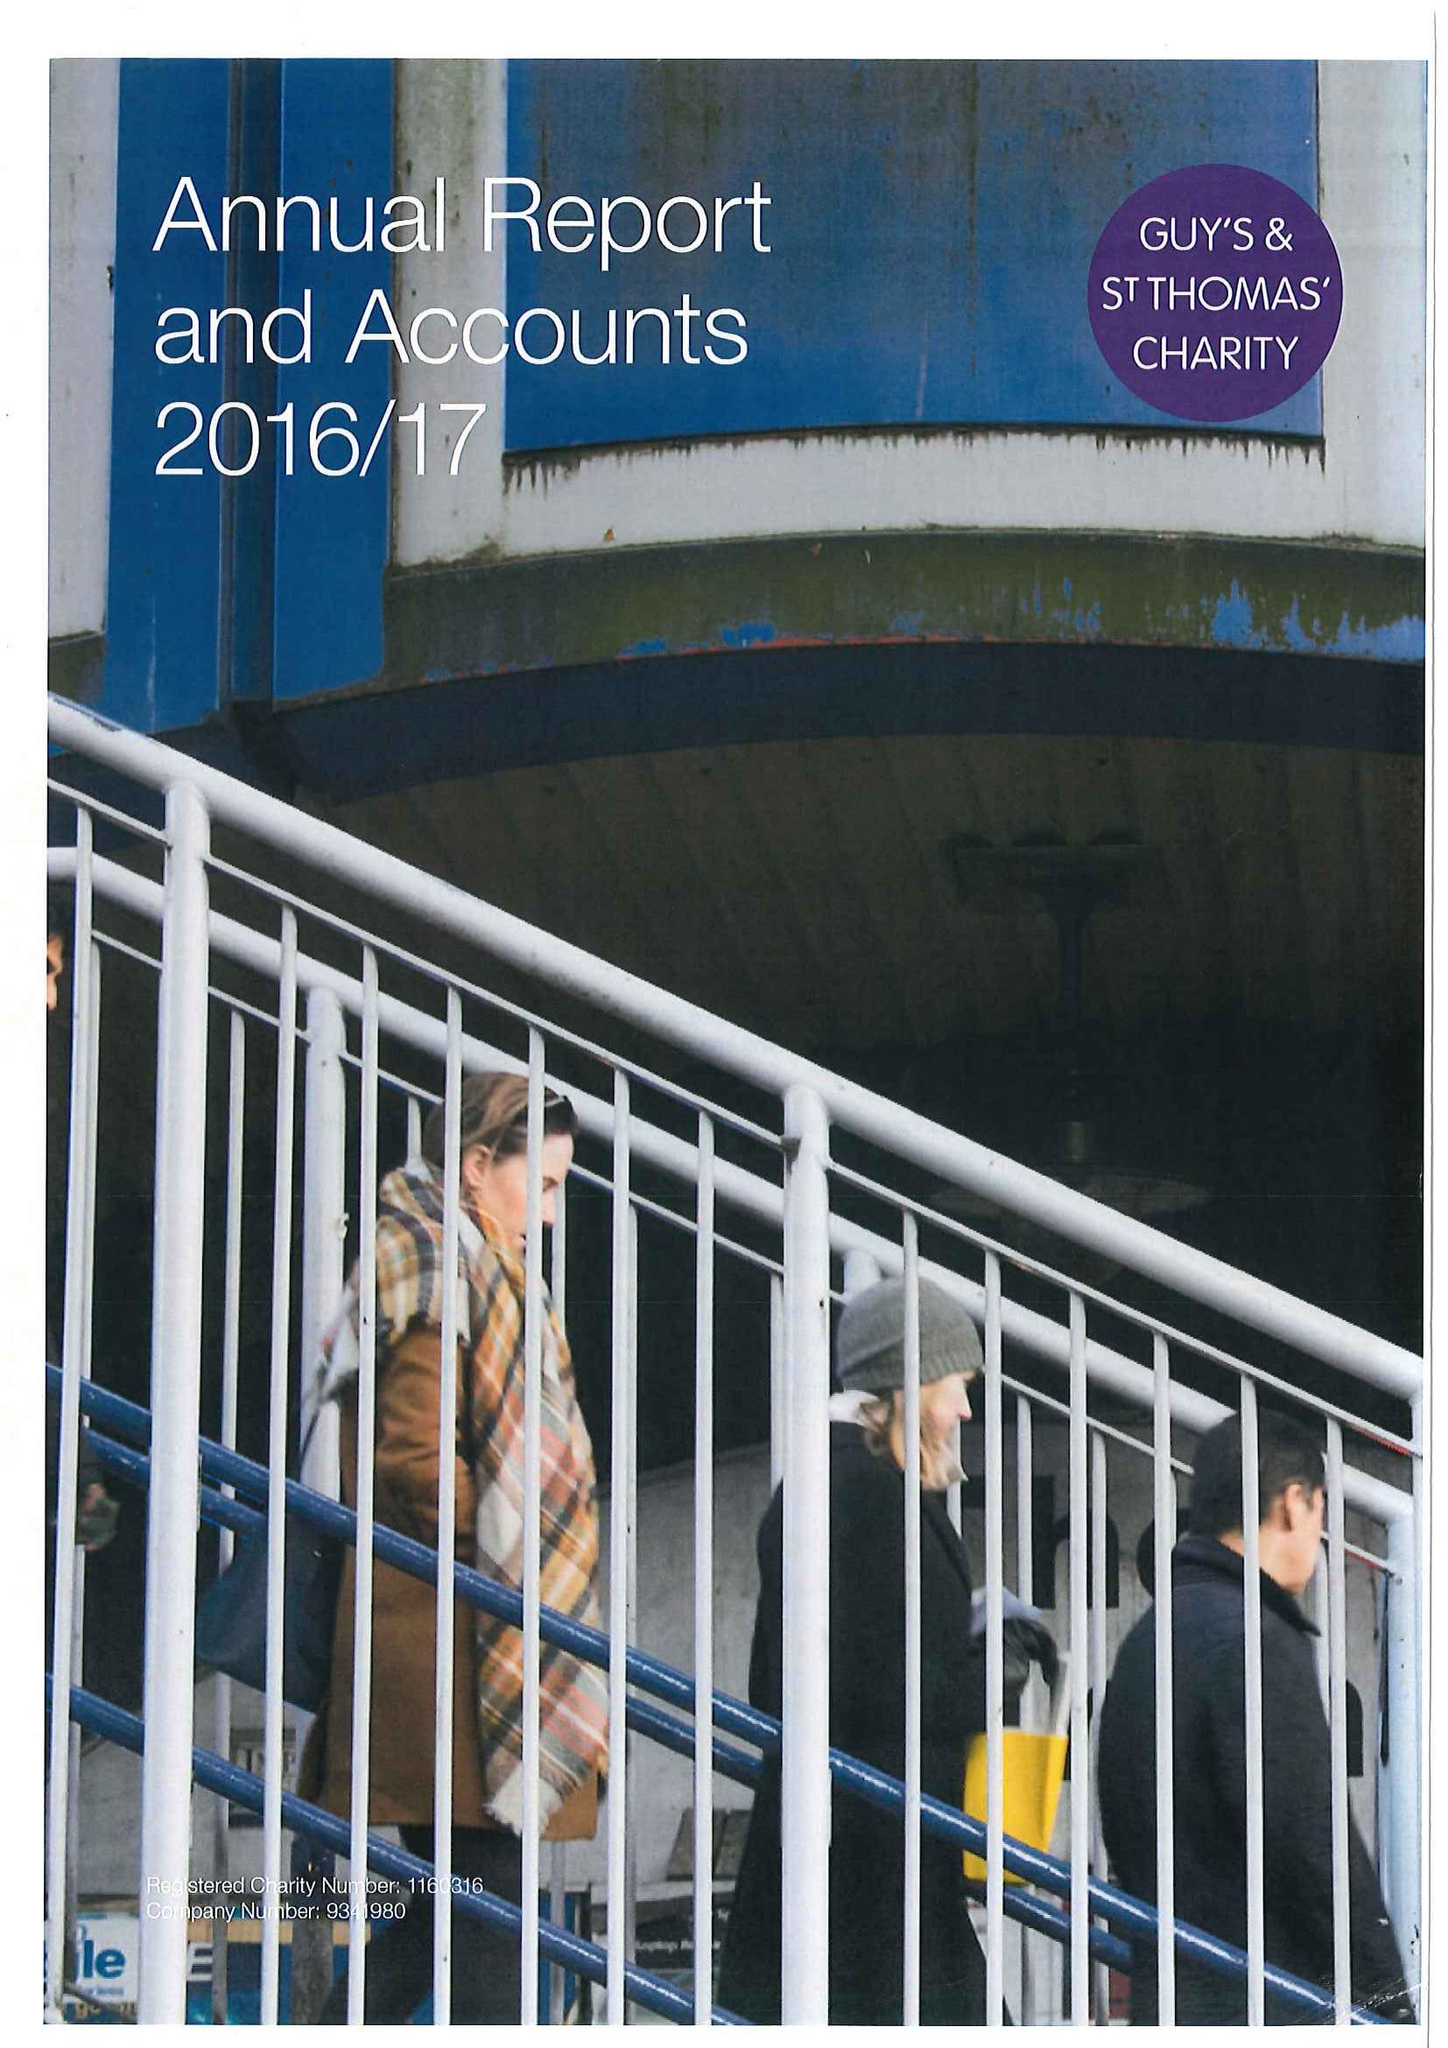What is the value for the spending_annually_in_british_pounds?
Answer the question using a single word or phrase. 30600000.00 